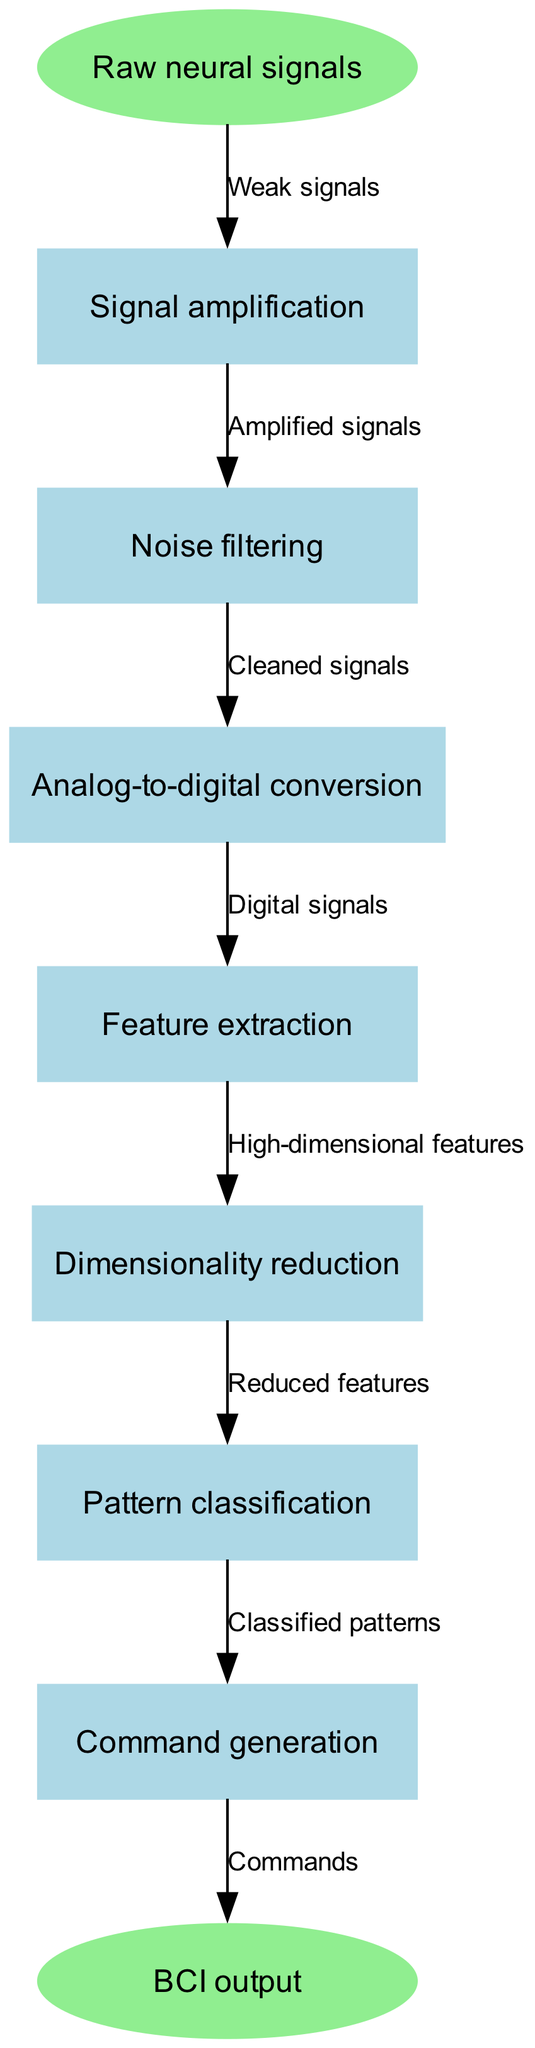What is the first step in the neural signal processing pipeline? The diagram shows "Raw neural signals" as the starting point, indicating that it is the first step in the pipeline.
Answer: Raw neural signals How many nodes are present in the diagram? By counting the nodes listed (including start and end nodes), there are a total of 8 nodes: one start node, six processing nodes, and one end node.
Answer: 8 What type of signals are passed to the "Noise filtering" step? Referring to the edge from "Noise filtering," it receives "Cleaned signals" from the previous step, showing what type of signals are processed there.
Answer: Cleaned signals Which node comes after "Dimensionality reduction"? The diagram indicates that "Pattern classification" follows "Dimensionality reduction," showing the flow from one process to another.
Answer: Pattern classification What is the label used for the edge between "Signal amplification" and "Noise filtering"? The edge label described shows the transition between these nodes with the phrase "Amplified signals" which denotes the output of the amplification process.
Answer: Amplified signals What is the relationship between "Feature extraction" and "Dimensionality reduction"? "Feature extraction" sends its output, labeled "High-dimensional features" to "Dimensionality reduction," indicating a direct processing relationship between these two steps.
Answer: High-dimensional features What is the final output of the neural signal processing pipeline? The end node labeled "BCI output" represents the final result after the processing steps are completed.
Answer: BCI output What kind of signals enter the "Analog-to-digital conversion" step? The input to "Analog-to-digital conversion" is shown to be "Digital signals"; this indicates what signals are transformed in that process.
Answer: Digital signals What label is associated with the connection from "Pattern classification" to "Command generation"? The edge label indicates the nature of data being transferred, which is "Classified patterns." This describes the type of information passed to the next node.
Answer: Classified patterns 